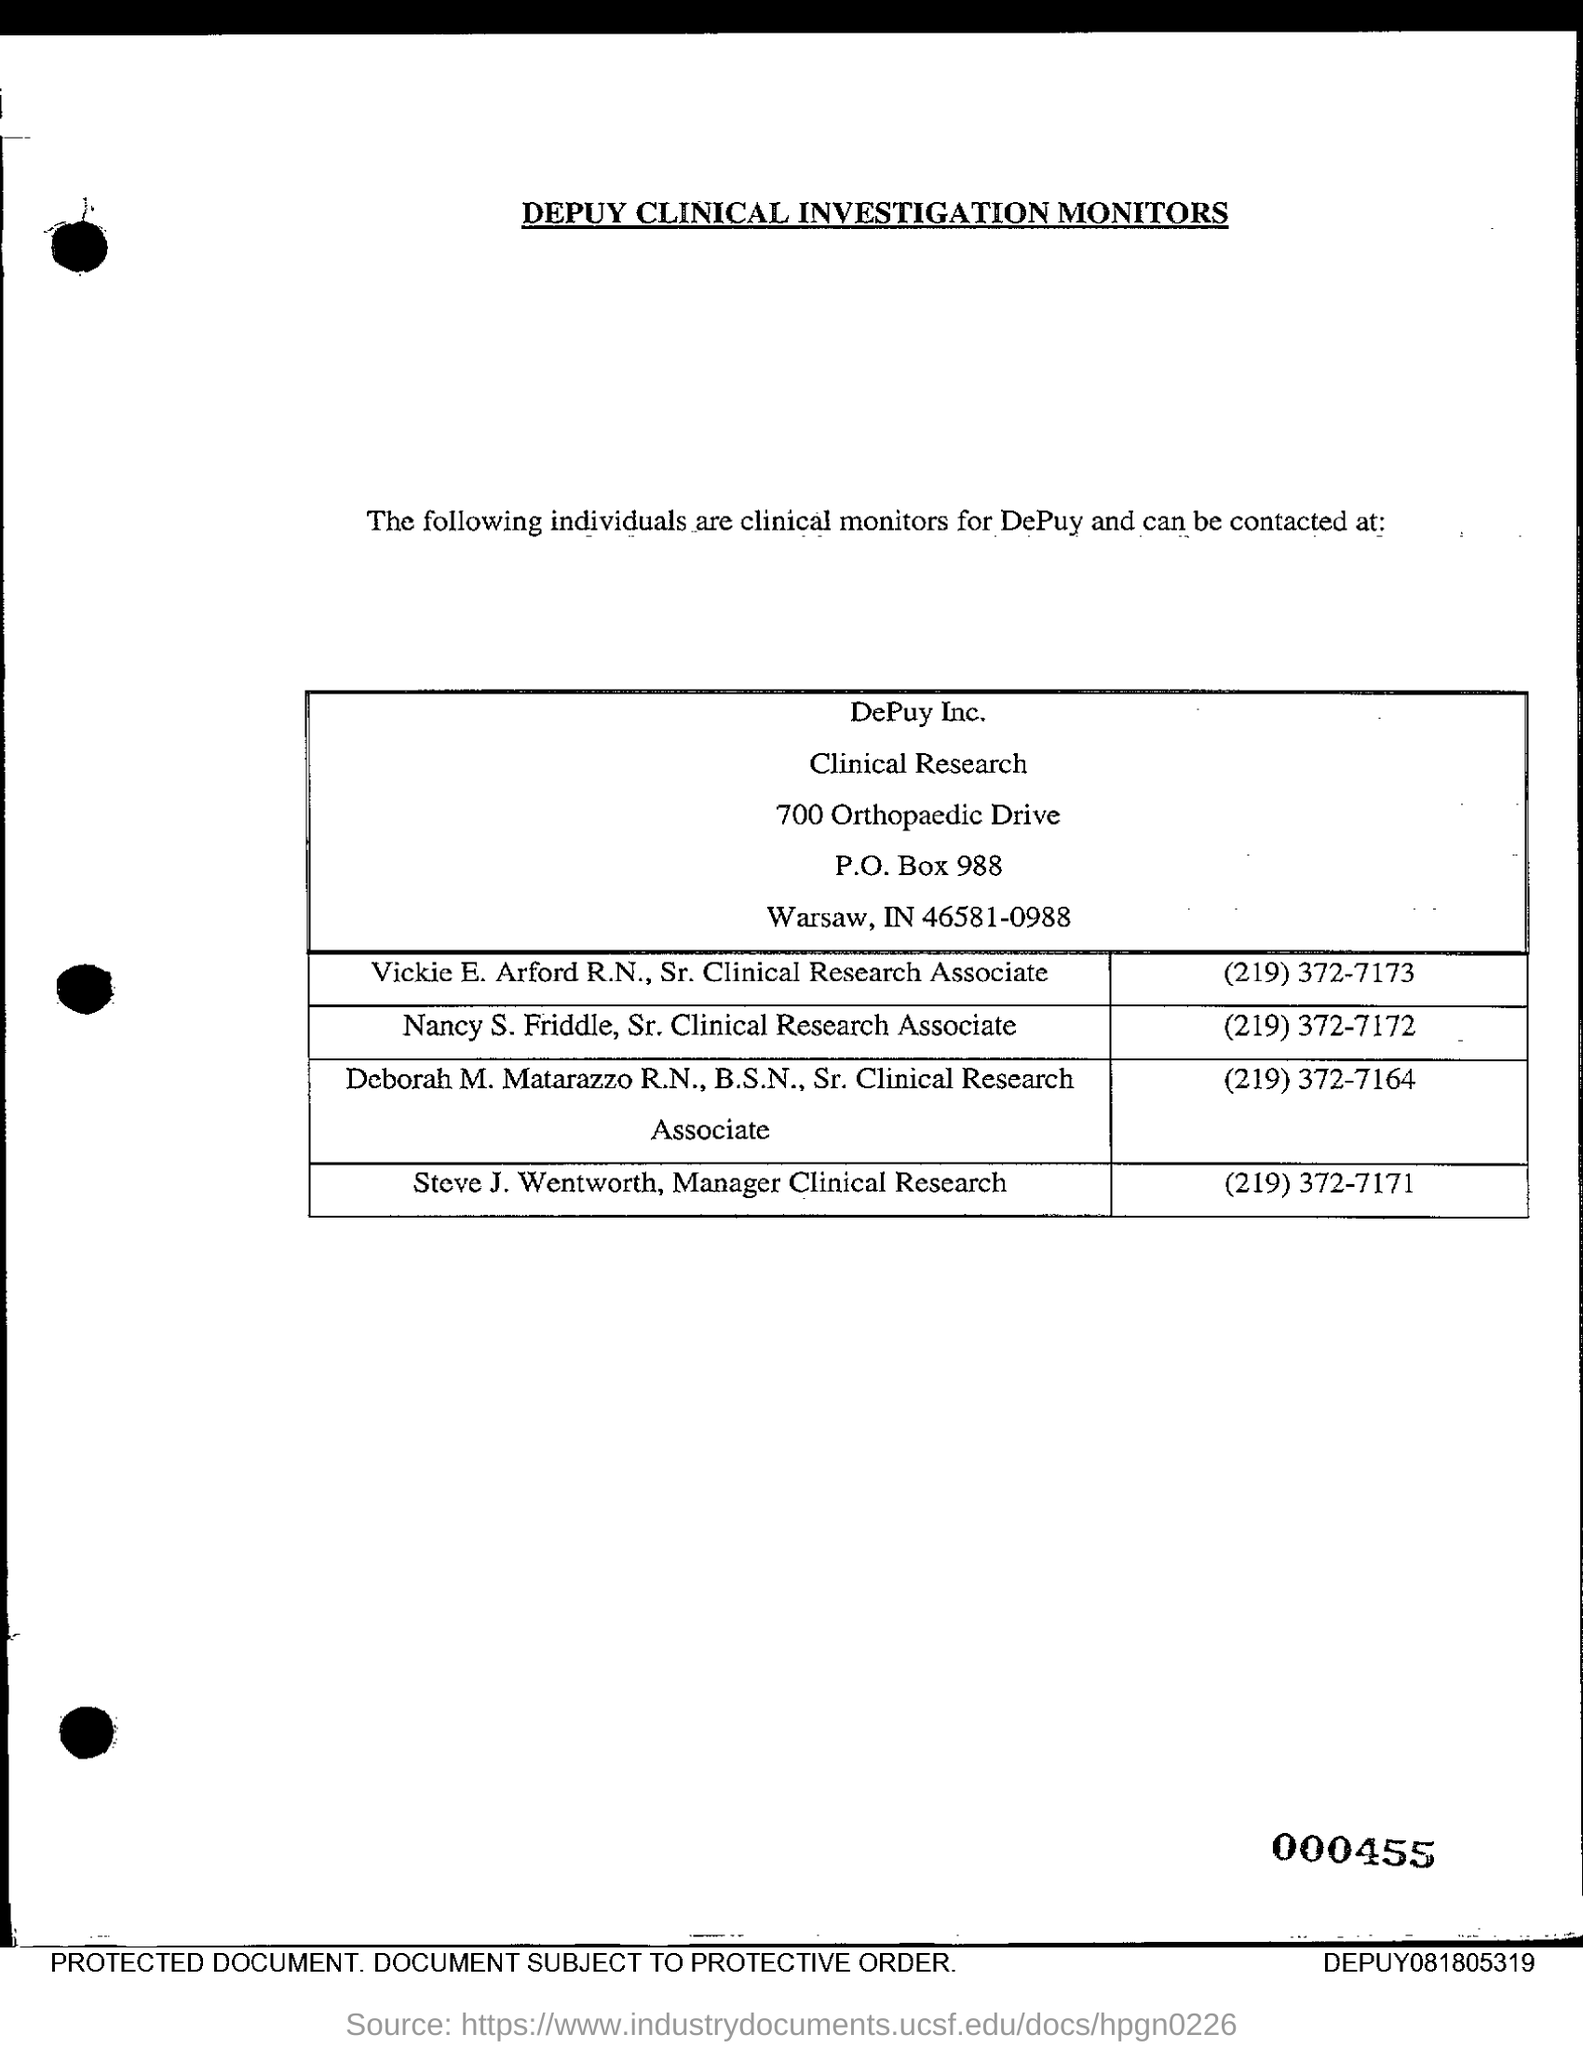Indicate a few pertinent items in this graphic. The name of the Manager of Clinical Research is Steve J. Wentworth. The zip code mentioned in the document is 46581-0988. The title of this document, as stated in capital letters, is: DEPUY CLINICAL INVESTIGATION MONITORS... The number of manager clinical research to be contacted is (219) 372-7171. The P.O. Box number given is 988. 